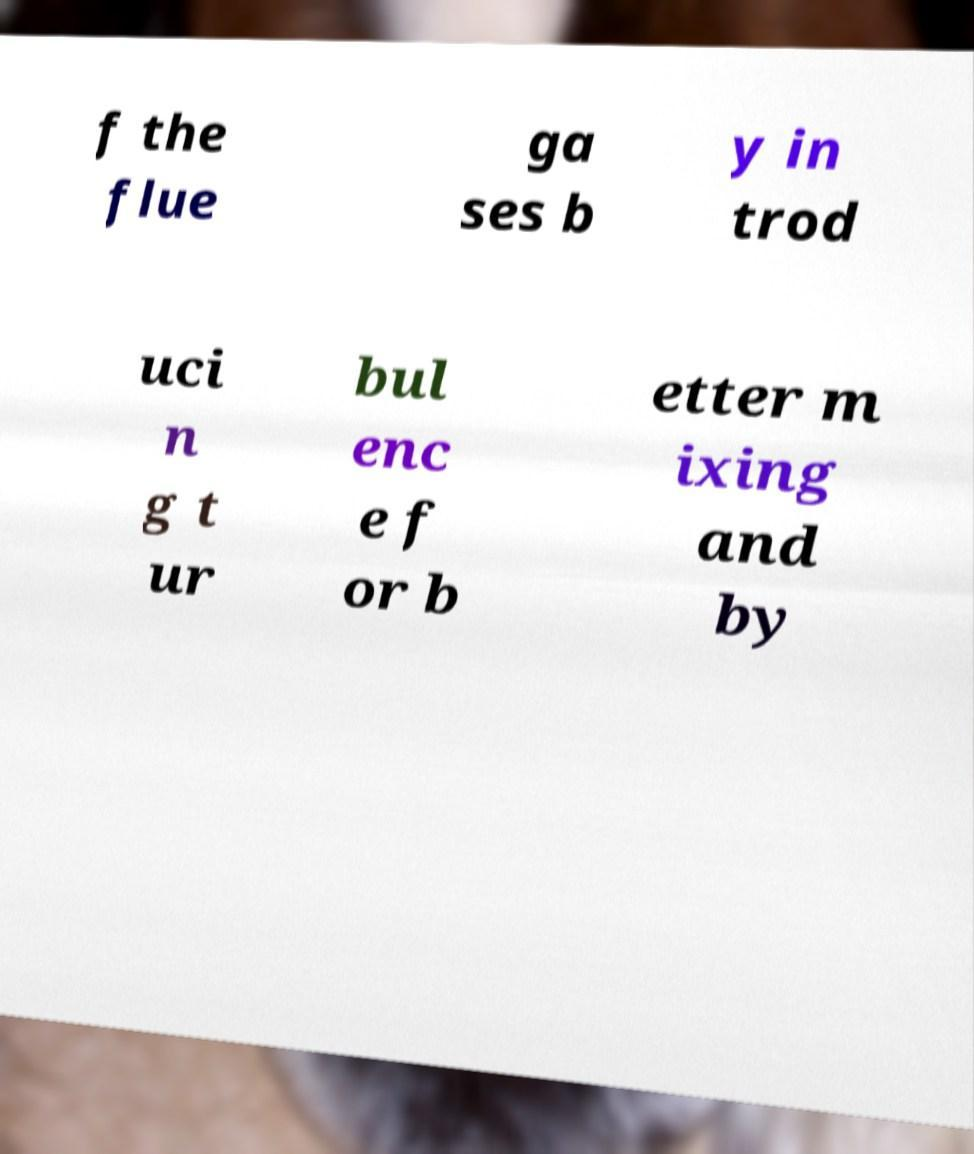There's text embedded in this image that I need extracted. Can you transcribe it verbatim? f the flue ga ses b y in trod uci n g t ur bul enc e f or b etter m ixing and by 